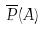Convert formula to latex. <formula><loc_0><loc_0><loc_500><loc_500>\overline { P } ( A )</formula> 